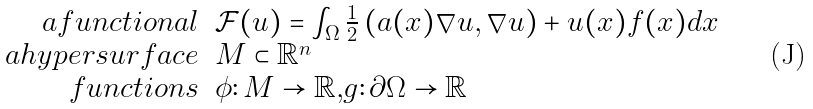Convert formula to latex. <formula><loc_0><loc_0><loc_500><loc_500>\begin{array} { r l } a f u n c t i o n a l & \mathcal { F } ( u ) = \int _ { \Omega } \frac { 1 } { 2 } \left ( a ( x ) \nabla u , \nabla u \right ) + u ( x ) f ( x ) d x \\ a h y p e r s u r f a c e & M \subset \mathbb { R } ^ { n } \\ f u n c t i o n s & \phi \colon M \to \mathbb { R , } g \colon \partial \Omega \to \mathbb { R } \\ \end{array}</formula> 